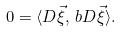Convert formula to latex. <formula><loc_0><loc_0><loc_500><loc_500>0 = \langle D \vec { \xi } , \, b D \vec { \xi } \rangle .</formula> 